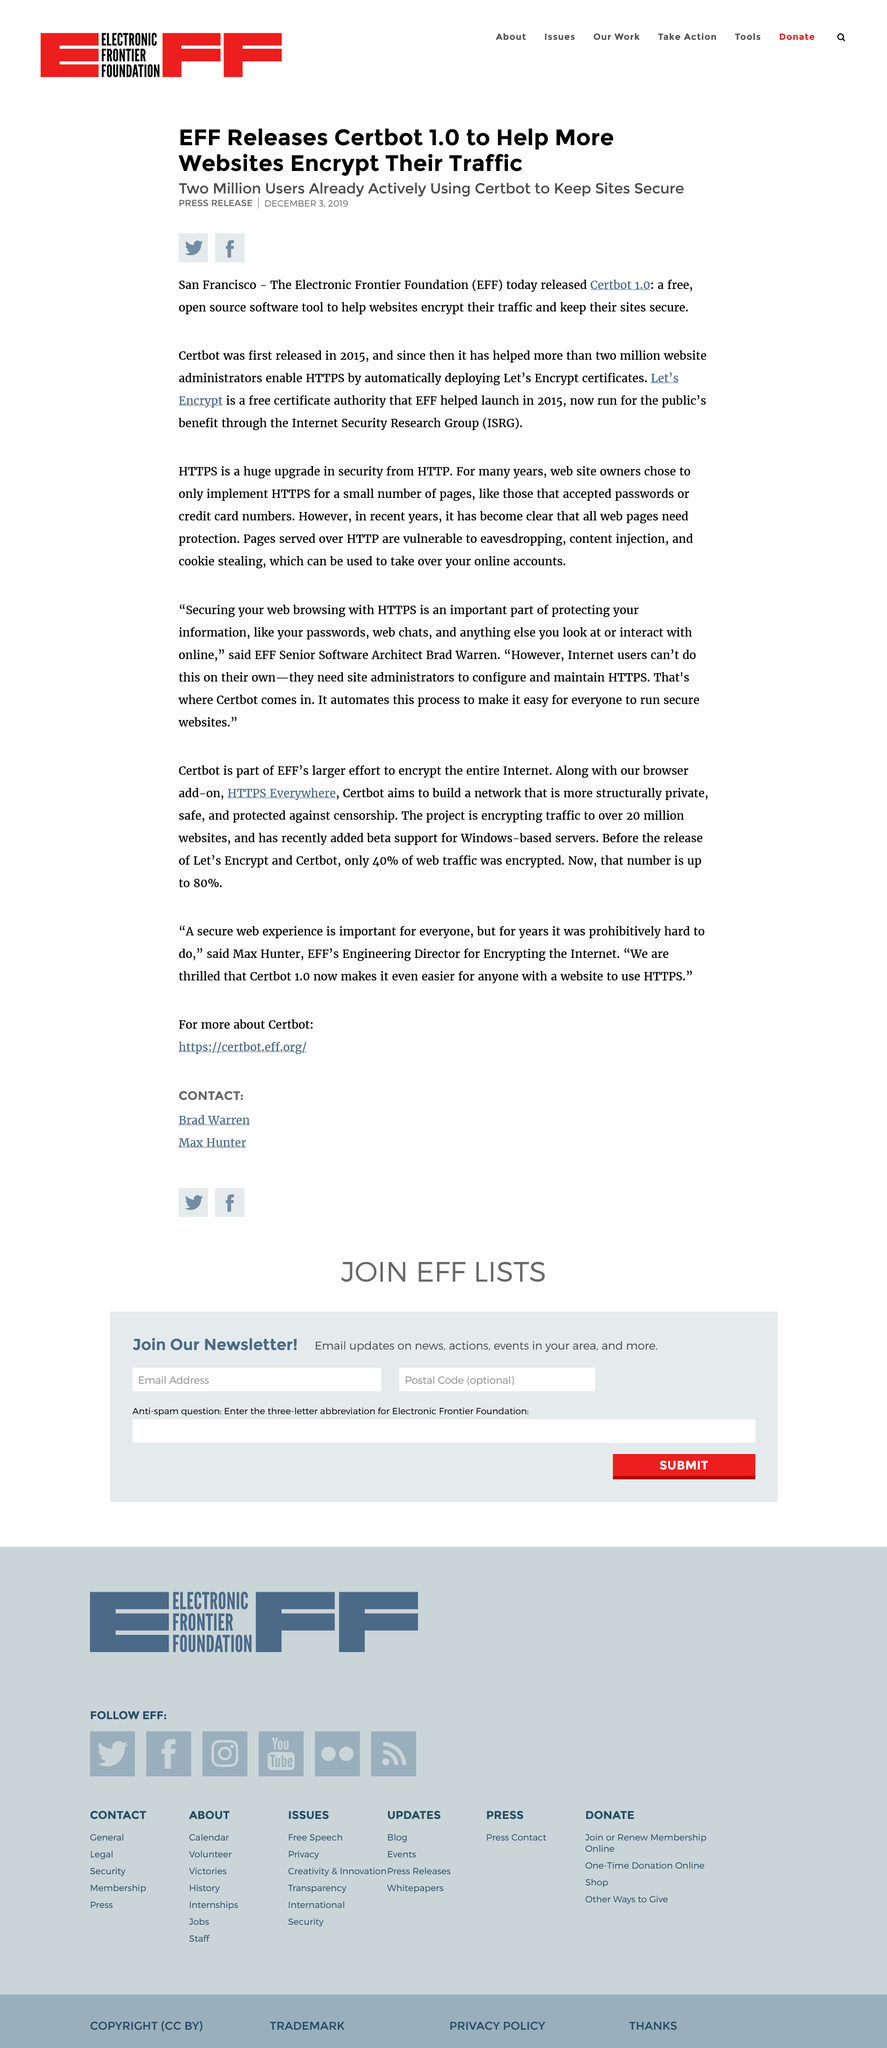Identify some key points in this picture. Certbot was first released in 2015. On December 3, 2019, EFF released Certbot 1.0, as stated in a press release. 